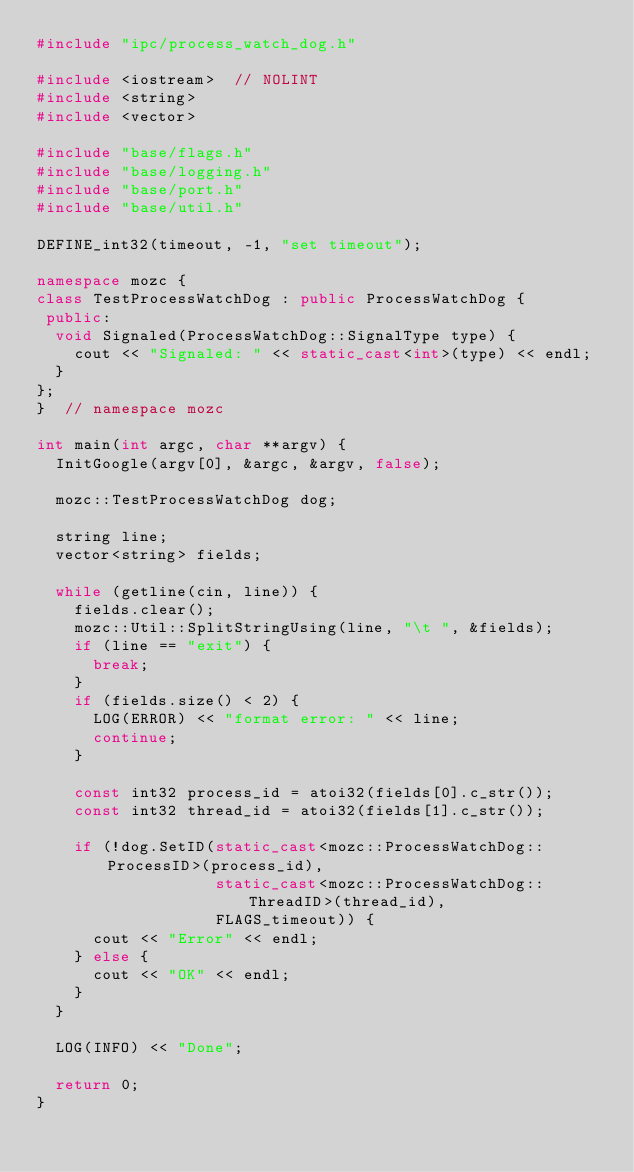<code> <loc_0><loc_0><loc_500><loc_500><_C++_>#include "ipc/process_watch_dog.h"

#include <iostream>  // NOLINT
#include <string>
#include <vector>

#include "base/flags.h"
#include "base/logging.h"
#include "base/port.h"
#include "base/util.h"

DEFINE_int32(timeout, -1, "set timeout");

namespace mozc {
class TestProcessWatchDog : public ProcessWatchDog {
 public:
  void Signaled(ProcessWatchDog::SignalType type) {
    cout << "Signaled: " << static_cast<int>(type) << endl;
  }
};
}  // namespace mozc

int main(int argc, char **argv) {
  InitGoogle(argv[0], &argc, &argv, false);

  mozc::TestProcessWatchDog dog;

  string line;
  vector<string> fields;

  while (getline(cin, line)) {
    fields.clear();
    mozc::Util::SplitStringUsing(line, "\t ", &fields);
    if (line == "exit") {
      break;
    }
    if (fields.size() < 2) {
      LOG(ERROR) << "format error: " << line;
      continue;
    }

    const int32 process_id = atoi32(fields[0].c_str());
    const int32 thread_id = atoi32(fields[1].c_str());

    if (!dog.SetID(static_cast<mozc::ProcessWatchDog::ProcessID>(process_id),
                   static_cast<mozc::ProcessWatchDog::ThreadID>(thread_id),
                   FLAGS_timeout)) {
      cout << "Error" << endl;
    } else {
      cout << "OK" << endl;
    }
  }

  LOG(INFO) << "Done";

  return 0;
}
</code> 